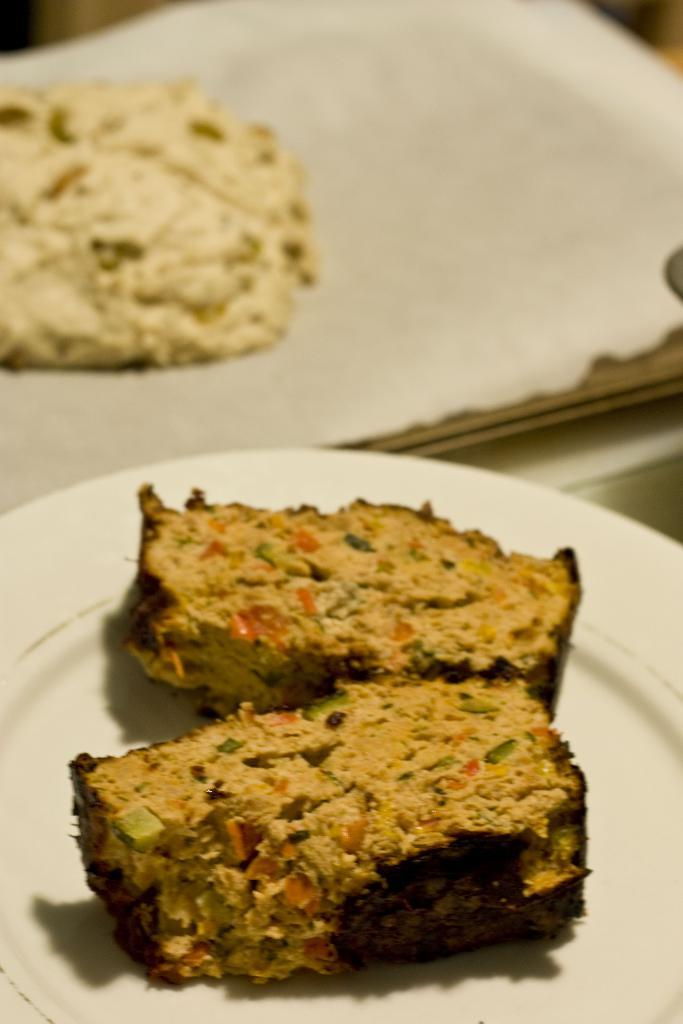What objects are present on the surface in the image? There are plates in the image. What is on the plates? The plates have food on them. Can you describe the surface where the plates are placed? The plates are on a surface. What type of string is being used to tie the goose in the image? There is no goose or string present in the image. Is the ghost visible in the image? There is no ghost present in the image. 